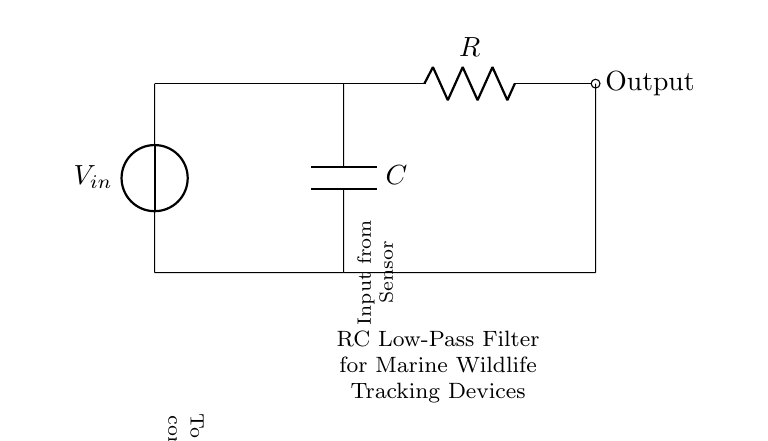What is the input source for this RC circuit? The circuit shows that the input source is labeled as V_in. This is indicated directly in the diagram where a voltage source is connected.
Answer: V_in What component determines the filtering effect in this RC circuit? The filtering effect in the RC circuit is determined by the capacitor (C). It interacts with the resistor (R) to define the frequency characteristics of the filter.
Answer: C Which direction does the output flow in this circuit? The output flows to the right, as indicated by the arrow on the connection from the resistor to the microcontroller output.
Answer: To the microcontroller What does the resistor represent in this RC filter circuit? The resistor (R) in the RC filter circuit represents the resistance that affects how quickly the capacitor charges and discharges, thus influencing the cutoff frequency of the filter.
Answer: Resistance If the capacitor value is increased, what happens to the cutoff frequency? Increasing the capacitor value decreases the cutoff frequency. The cutoff frequency is inversely proportional to capacitance in an RC filter, meaning larger capacitance allows lower frequencies to pass.
Answer: Decreases What type of filter is represented by this RC circuit? The circuit represents a low-pass filter, which allows signals of lower frequencies to pass while attenuating higher frequency signals.
Answer: Low-pass filter Which component provides the voltage drop in the circuit? The voltage drop in this circuit is provided by the resistor (R), as it converts electrical energy into heat due to the current flowing through it.
Answer: R 